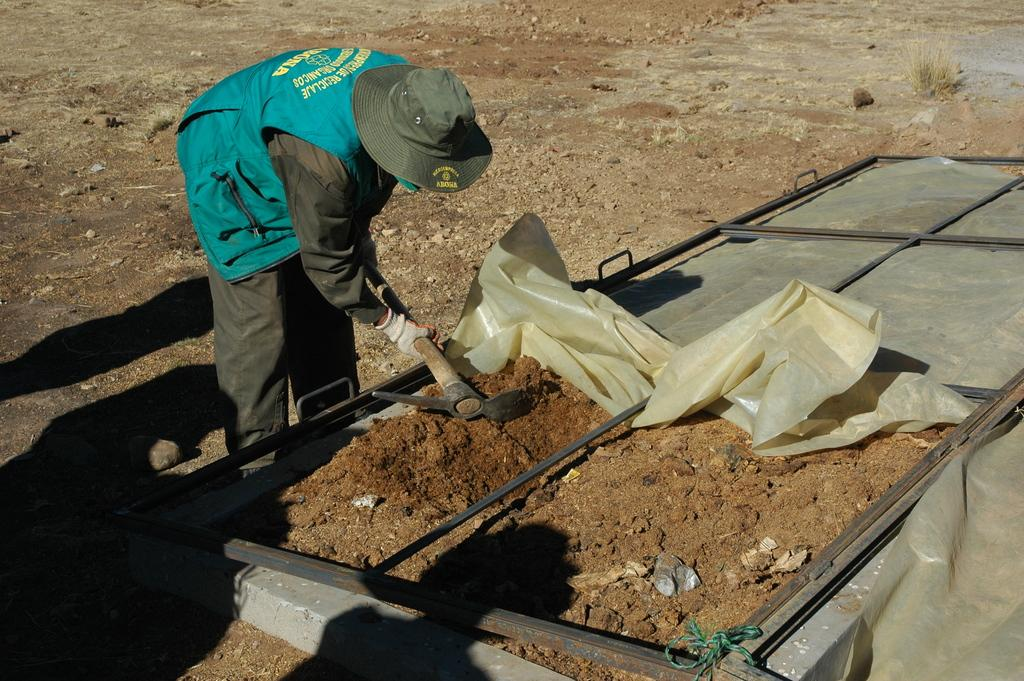What can be seen in the image related to a person? There is a person in the image. What is the person wearing on their head? The person is wearing a cap. What type of clothing is the person wearing on their upper body? The person is wearing a jacket. What is the person holding in their hand? The person is holding an object in their hand. What type of surface is visible at the bottom of the image? There is soil visible at the bottom of the image. What kind of structure is present in the image? There is a metal frame in the image. What is covering the object in the image? There is a cover in the image. How many rails can be seen in the image? There are no rails present in the image. What is the person looking at in the image? The provided facts do not mention what the person is looking at, so we cannot definitively answer this question. 